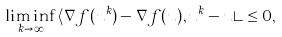Convert formula to latex. <formula><loc_0><loc_0><loc_500><loc_500>\liminf _ { k \rightarrow \infty } \, \langle \nabla f ( u ^ { k } ) - \nabla f ( u ) , u ^ { k } - u \rangle \leq 0 ,</formula> 